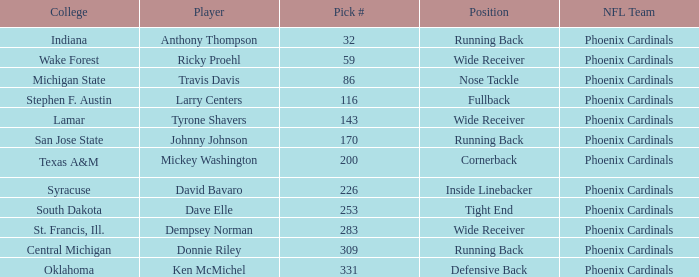Which NFL team has a pick# less than 200 for Travis Davis? Phoenix Cardinals. Could you parse the entire table? {'header': ['College', 'Player', 'Pick #', 'Position', 'NFL Team'], 'rows': [['Indiana', 'Anthony Thompson', '32', 'Running Back', 'Phoenix Cardinals'], ['Wake Forest', 'Ricky Proehl', '59', 'Wide Receiver', 'Phoenix Cardinals'], ['Michigan State', 'Travis Davis', '86', 'Nose Tackle', 'Phoenix Cardinals'], ['Stephen F. Austin', 'Larry Centers', '116', 'Fullback', 'Phoenix Cardinals'], ['Lamar', 'Tyrone Shavers', '143', 'Wide Receiver', 'Phoenix Cardinals'], ['San Jose State', 'Johnny Johnson', '170', 'Running Back', 'Phoenix Cardinals'], ['Texas A&M', 'Mickey Washington', '200', 'Cornerback', 'Phoenix Cardinals'], ['Syracuse', 'David Bavaro', '226', 'Inside Linebacker', 'Phoenix Cardinals'], ['South Dakota', 'Dave Elle', '253', 'Tight End', 'Phoenix Cardinals'], ['St. Francis, Ill.', 'Dempsey Norman', '283', 'Wide Receiver', 'Phoenix Cardinals'], ['Central Michigan', 'Donnie Riley', '309', 'Running Back', 'Phoenix Cardinals'], ['Oklahoma', 'Ken McMichel', '331', 'Defensive Back', 'Phoenix Cardinals']]} 